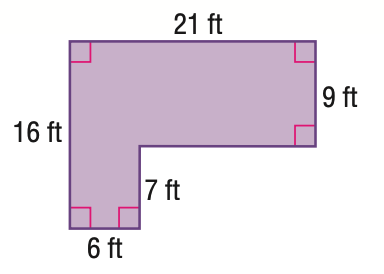Question: Find the area of the figure. Round to the nearest tenth.
Choices:
A. 189
B. 231
C. 294
D. 336
Answer with the letter. Answer: B 